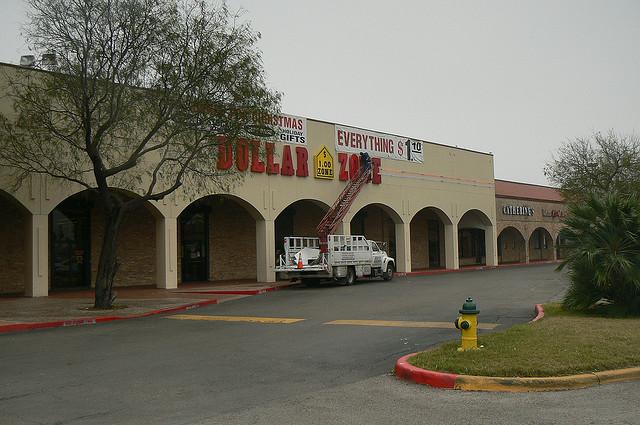What color is the hydrant?
Quick response, please. Yellow. Are they putting up or taking down the sign?
Short answer required. Taking down. Is this a dollar store?
Keep it brief. Yes. 